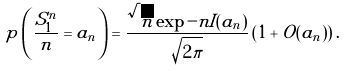Convert formula to latex. <formula><loc_0><loc_0><loc_500><loc_500>p \left ( \frac { S _ { 1 } ^ { n } } { n } = a _ { n } \right ) = \frac { \sqrt { n } \exp - n I ( a _ { n } ) } { \sqrt { 2 \pi } } \left ( 1 + O ( a _ { n } ) \right ) .</formula> 